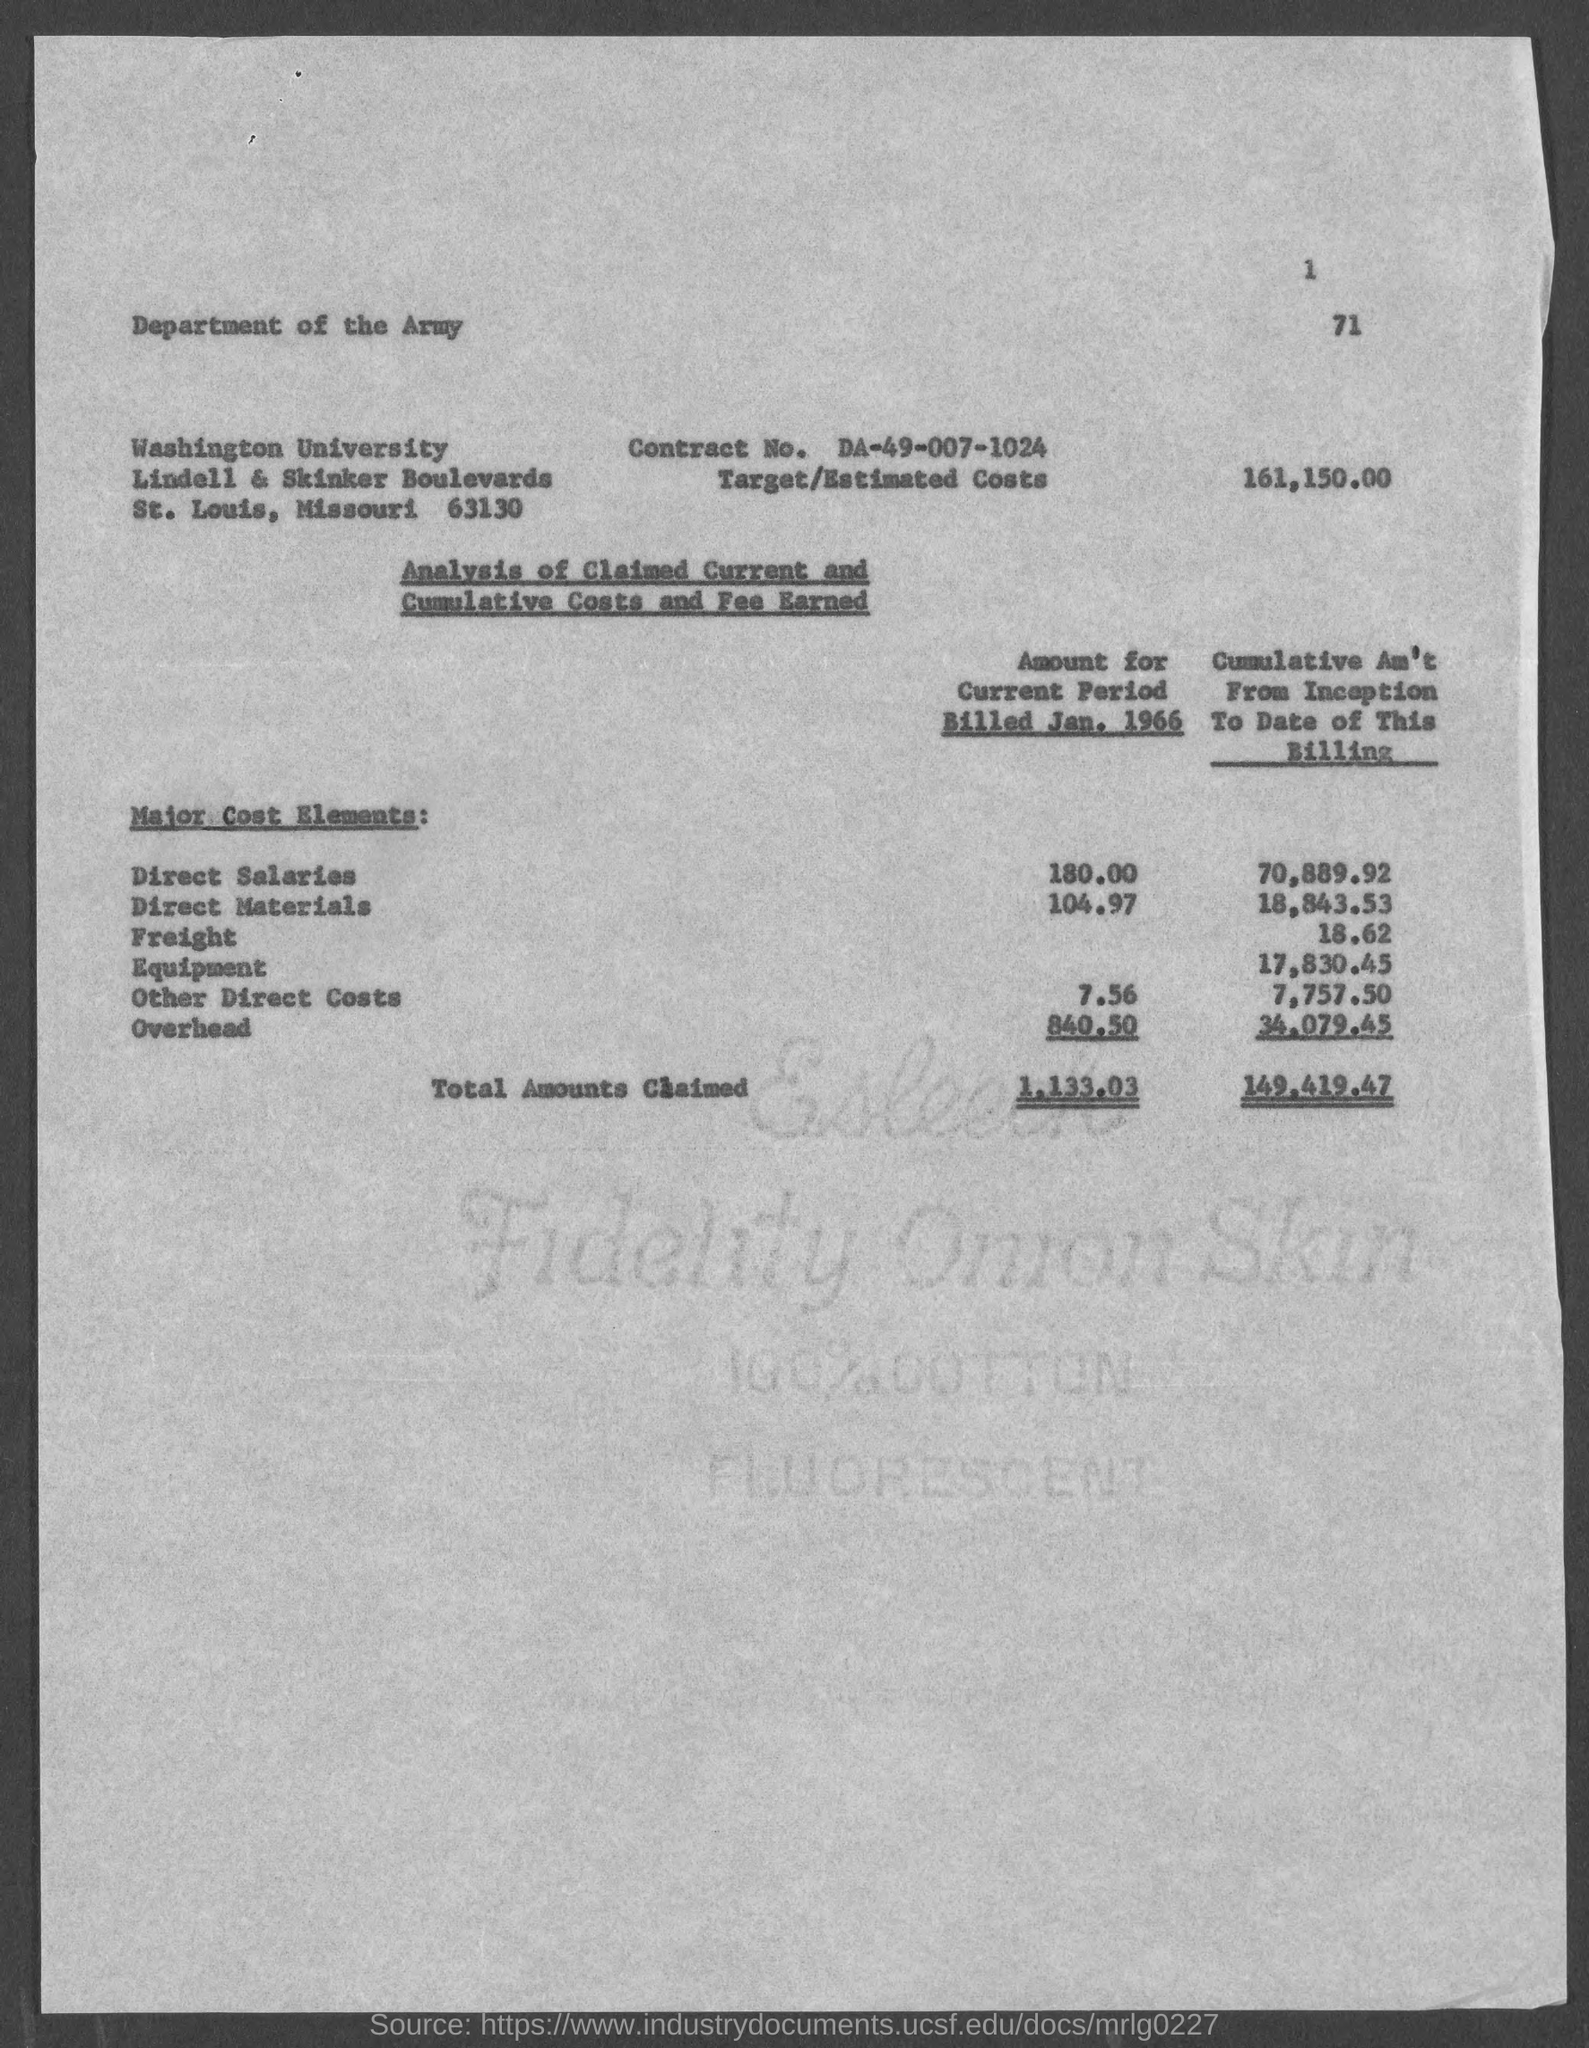What is the Contract No.?
Your answer should be very brief. DA-49-007-1024. What is the target/Estimated Costs?
Your answer should be very brief. 161,150.00. What is the Direct Salary amount for current period billed Jan. 1966?
Provide a short and direct response. 180.00. What is the Direct Materials amount for current period billed Jan. 1966?
Your response must be concise. 104.97. What is the Other Direct costs amount for current period billed Jan. 1966?
Your response must be concise. 7.56. What is the Total amounts claimed for current period billed Jan. 1966?
Your answer should be very brief. 1,133.03. What is the Total amounts claimed for cumulative Am't from Inception to date of this billing?
Offer a terse response. 149,419.47. What is the Overhead amounts claimed for cumulative Am't from Inception to date of this billing?
Provide a succinct answer. 34,079.45. 